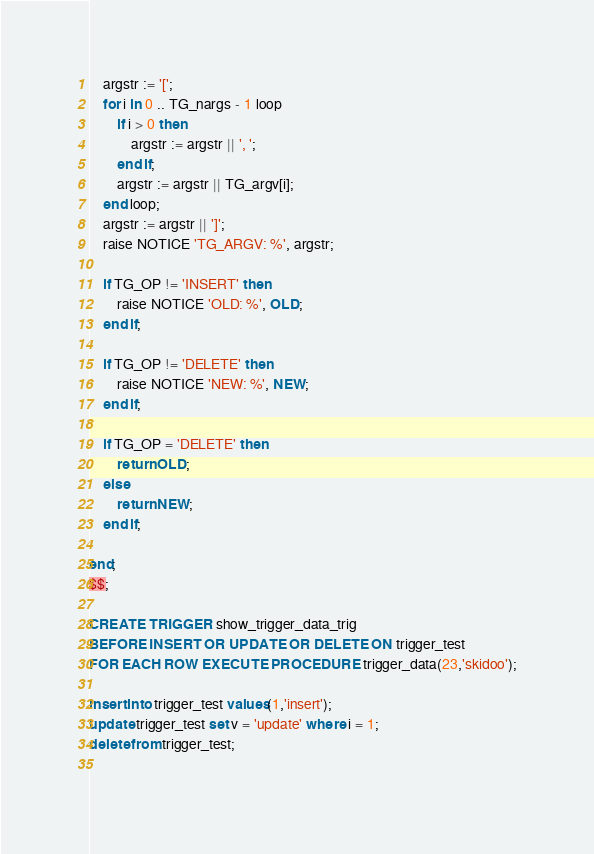<code> <loc_0><loc_0><loc_500><loc_500><_SQL_>	argstr := '[';
	for i in 0 .. TG_nargs - 1 loop
		if i > 0 then
			argstr := argstr || ', ';
		end if;
		argstr := argstr || TG_argv[i];
	end loop;
	argstr := argstr || ']';
	raise NOTICE 'TG_ARGV: %', argstr;

	if TG_OP != 'INSERT' then
		raise NOTICE 'OLD: %', OLD;
	end if;

	if TG_OP != 'DELETE' then
		raise NOTICE 'NEW: %', NEW;
	end if;

	if TG_OP = 'DELETE' then
		return OLD;
	else
		return NEW;
	end if;

end;
$$;

CREATE TRIGGER show_trigger_data_trig 
BEFORE INSERT OR UPDATE OR DELETE ON trigger_test
FOR EACH ROW EXECUTE PROCEDURE trigger_data(23,'skidoo');

insert into trigger_test values(1,'insert');
update trigger_test set v = 'update' where i = 1;
delete from trigger_test;
      </code> 